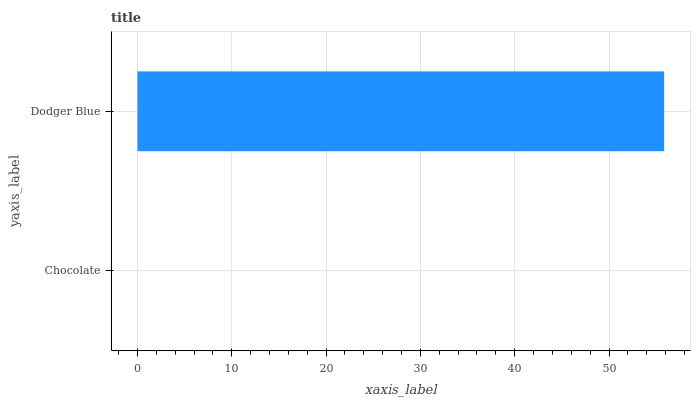Is Chocolate the minimum?
Answer yes or no. Yes. Is Dodger Blue the maximum?
Answer yes or no. Yes. Is Dodger Blue the minimum?
Answer yes or no. No. Is Dodger Blue greater than Chocolate?
Answer yes or no. Yes. Is Chocolate less than Dodger Blue?
Answer yes or no. Yes. Is Chocolate greater than Dodger Blue?
Answer yes or no. No. Is Dodger Blue less than Chocolate?
Answer yes or no. No. Is Dodger Blue the high median?
Answer yes or no. Yes. Is Chocolate the low median?
Answer yes or no. Yes. Is Chocolate the high median?
Answer yes or no. No. Is Dodger Blue the low median?
Answer yes or no. No. 